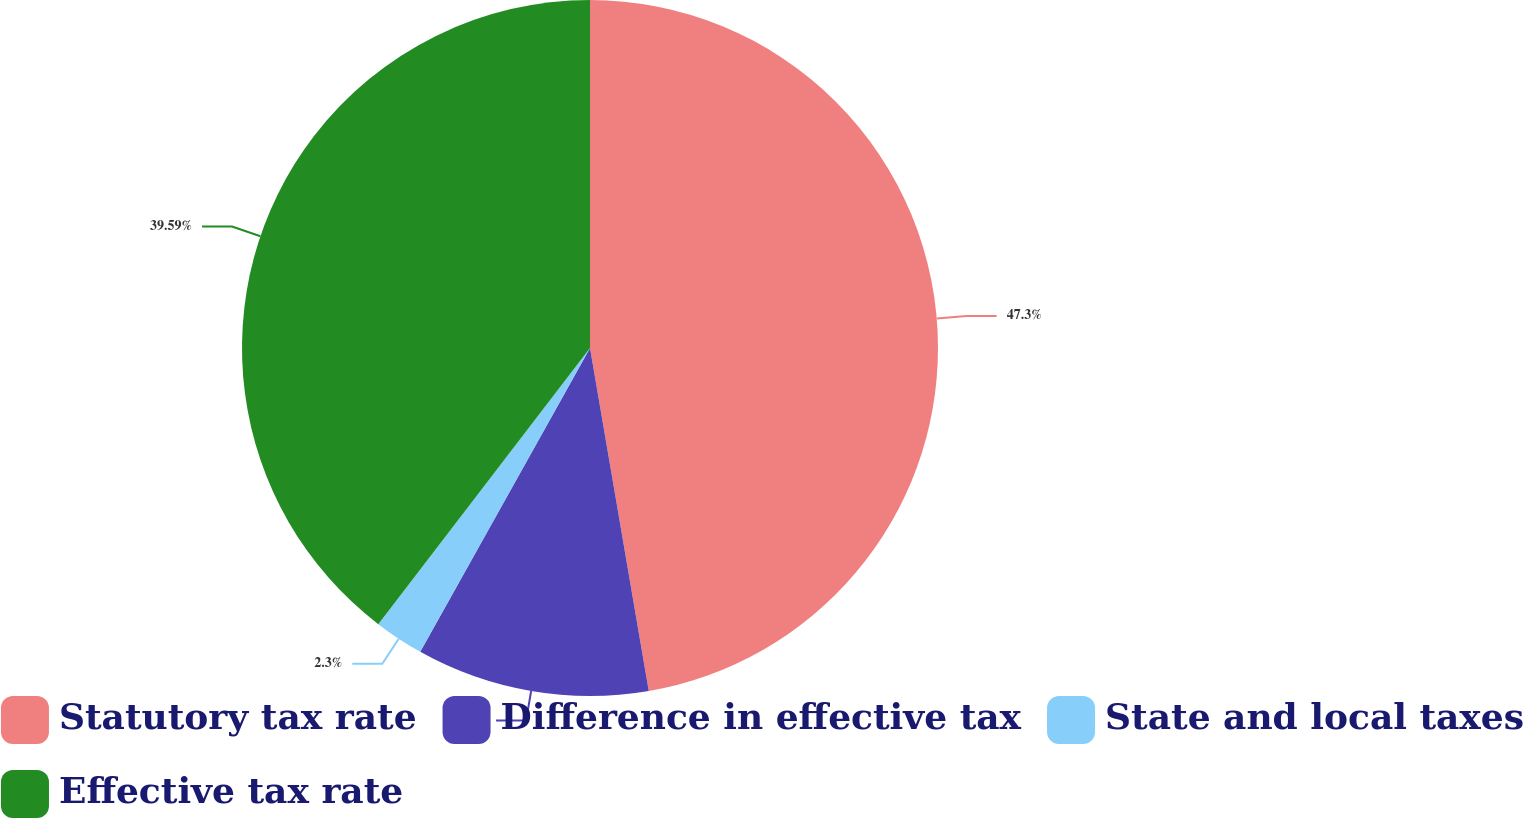Convert chart to OTSL. <chart><loc_0><loc_0><loc_500><loc_500><pie_chart><fcel>Statutory tax rate<fcel>Difference in effective tax<fcel>State and local taxes<fcel>Effective tax rate<nl><fcel>47.3%<fcel>10.81%<fcel>2.3%<fcel>39.59%<nl></chart> 